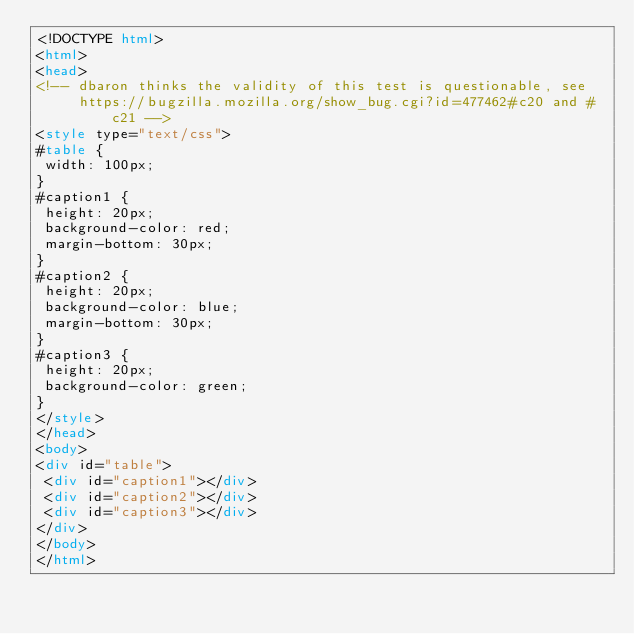<code> <loc_0><loc_0><loc_500><loc_500><_HTML_><!DOCTYPE html>
<html>
<head>
<!-- dbaron thinks the validity of this test is questionable, see
     https://bugzilla.mozilla.org/show_bug.cgi?id=477462#c20 and #c21 -->
<style type="text/css">
#table {
 width: 100px;
}
#caption1 {
 height: 20px;
 background-color: red;
 margin-bottom: 30px;
}
#caption2 {
 height: 20px;
 background-color: blue;
 margin-bottom: 30px;
}
#caption3 {
 height: 20px;
 background-color: green;
}
</style>
</head>
<body>
<div id="table">
 <div id="caption1"></div>
 <div id="caption2"></div>
 <div id="caption3"></div>
</div>
</body>
</html>
</code> 